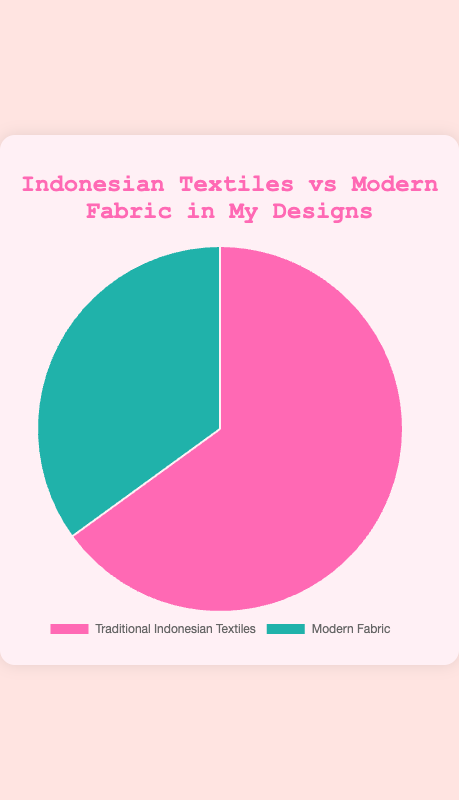What percentage of the materials used in personal designs is made up of Traditional Indonesian Textiles? The percentage is directly given in the figure under the category labeled 'Traditional Indonesian Textiles'.
Answer: 65% How much higher is the percentage of Traditional Indonesian Textiles than Modern Fabric in personal designs? Calculate the difference between the percentages of Traditional Indonesian Textiles and Modern Fabric. The difference is 65% - 35%.
Answer: 30% What is the total percentage represented in the pie chart? Since a pie chart represents 100% of a dataset, the total percentage is always 100%.
Answer: 100% Which category forms the larger part of your personal designs, Traditional Indonesian Textiles or Modern Fabric? Compare the percentages given: Traditional Indonesian Textiles is 65%, and Modern Fabric is 35%. 65% is greater than 35%.
Answer: Traditional Indonesian Textiles What fraction of the personal designs is composed of Modern Fabric? Convert the given percentage of Modern Fabric into a fraction. 35% translates to 35/100, which simplifies to 7/20.
Answer: 7/20 What is the ratio of Traditional Indonesian Textiles to Modern Fabric in your personal designs? The ratio is derived by comparing the two percentages: 65% to 35%. Simplify the ratio by dividing both numbers by 5.
Answer: 13:7 Which segment is represented by the color pink? Observe the colors of the segments in the pie chart. Traditional Indonesian Textiles are shown in pink.
Answer: Traditional Indonesian Textiles If you were to create 200 new designs, how many of those would likely feature Modern Fabric based on the given percentages? Use the percentage for Modern Fabric: 35%. Multiply 200 by 0.35 to get the number of designs featuring Modern Fabric.
Answer: 70 By how many times is the use of Traditional Indonesian Textiles greater than Modern Fabric in your designs? Divide the percentage of Traditional Indonesian Textiles by the percentage of Modern Fabric: 65% / 35%. This simplifies to approximately 1.857.
Answer: 1.857 If you decide to increase the share of Modern Fabric in new designs by 10%, what would be the new percentage for Modern Fabric, and what would be the corresponding percentage for Traditional Indonesian Textiles? Adding 10% to the current Modern Fabric percentage (35%) gives 45%. Since the total must be 100%, subtract 45% from 100% for the new Traditional Indonesian Textiles percentage.
Answer: Modern Fabric: 45%, Traditional Indonesian Textiles: 55% 